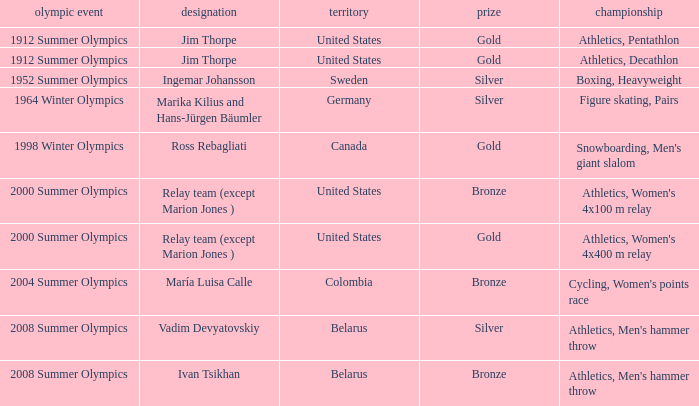Which event is in the 1952 summer olympics? Boxing, Heavyweight. Would you mind parsing the complete table? {'header': ['olympic event', 'designation', 'territory', 'prize', 'championship'], 'rows': [['1912 Summer Olympics', 'Jim Thorpe', 'United States', 'Gold', 'Athletics, Pentathlon'], ['1912 Summer Olympics', 'Jim Thorpe', 'United States', 'Gold', 'Athletics, Decathlon'], ['1952 Summer Olympics', 'Ingemar Johansson', 'Sweden', 'Silver', 'Boxing, Heavyweight'], ['1964 Winter Olympics', 'Marika Kilius and Hans-Jürgen Bäumler', 'Germany', 'Silver', 'Figure skating, Pairs'], ['1998 Winter Olympics', 'Ross Rebagliati', 'Canada', 'Gold', "Snowboarding, Men's giant slalom"], ['2000 Summer Olympics', 'Relay team (except Marion Jones )', 'United States', 'Bronze', "Athletics, Women's 4x100 m relay"], ['2000 Summer Olympics', 'Relay team (except Marion Jones )', 'United States', 'Gold', "Athletics, Women's 4x400 m relay"], ['2004 Summer Olympics', 'María Luisa Calle', 'Colombia', 'Bronze', "Cycling, Women's points race"], ['2008 Summer Olympics', 'Vadim Devyatovskiy', 'Belarus', 'Silver', "Athletics, Men's hammer throw"], ['2008 Summer Olympics', 'Ivan Tsikhan', 'Belarus', 'Bronze', "Athletics, Men's hammer throw"]]} 